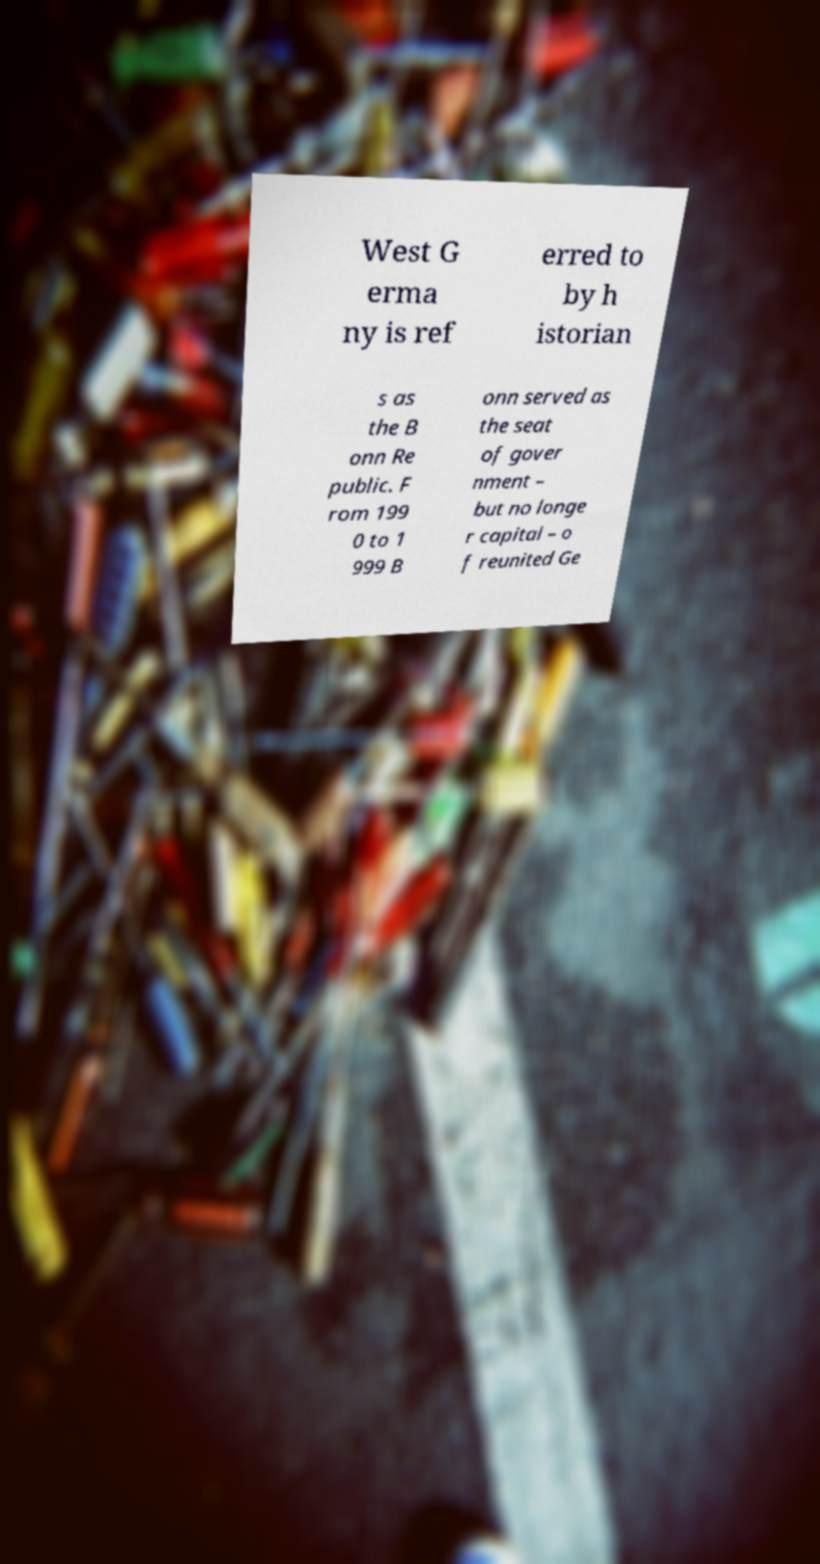Please identify and transcribe the text found in this image. West G erma ny is ref erred to by h istorian s as the B onn Re public. F rom 199 0 to 1 999 B onn served as the seat of gover nment – but no longe r capital – o f reunited Ge 